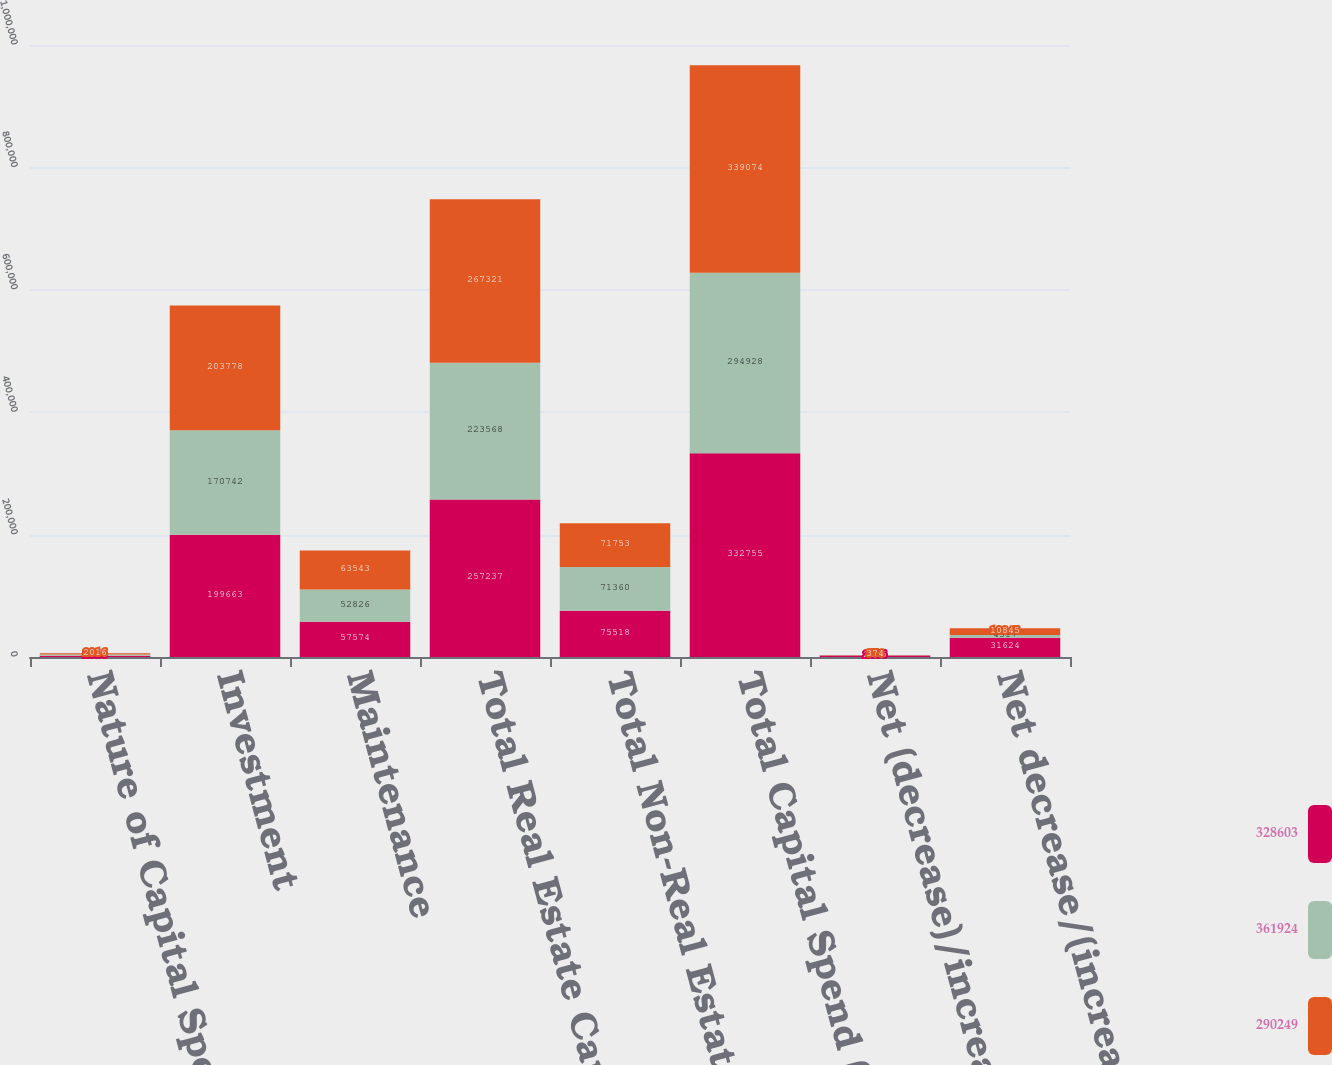Convert chart to OTSL. <chart><loc_0><loc_0><loc_500><loc_500><stacked_bar_chart><ecel><fcel>Nature of Capital Spend (in<fcel>Investment<fcel>Maintenance<fcel>Total Real Estate Capital<fcel>Total Non-Real Estate Capital<fcel>Total Capital Spend (on<fcel>Net (decrease)/increase in<fcel>Net decrease/(increase)<nl><fcel>328603<fcel>2014<fcel>199663<fcel>57574<fcel>257237<fcel>75518<fcel>332755<fcel>2455<fcel>31624<nl><fcel>361924<fcel>2015<fcel>170742<fcel>52826<fcel>223568<fcel>71360<fcel>294928<fcel>362<fcel>4317<nl><fcel>290249<fcel>2016<fcel>203778<fcel>63543<fcel>267321<fcel>71753<fcel>339074<fcel>374<fcel>10845<nl></chart> 